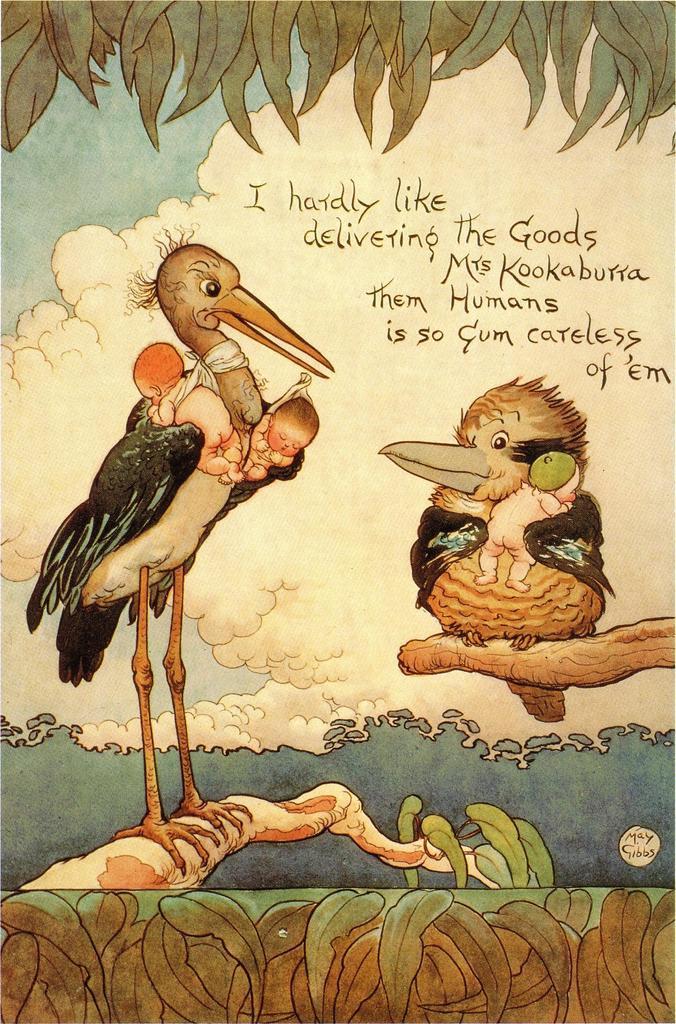How would you summarize this image in a sentence or two? In this picture, it looks like cartoons of birds and babies. Birds are standing on the branches. Behind the birds those are looking like leaves and the sky. On the image it is written something. 